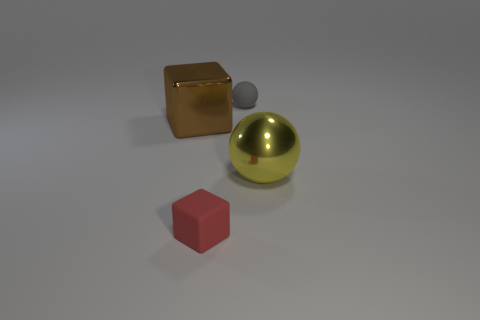Add 4 small brown metal spheres. How many objects exist? 8 Subtract all yellow balls. How many balls are left? 1 Subtract 2 cubes. How many cubes are left? 0 Subtract 1 yellow spheres. How many objects are left? 3 Subtract all green spheres. Subtract all red cylinders. How many spheres are left? 2 Subtract all cyan metallic cylinders. Subtract all big balls. How many objects are left? 3 Add 3 big objects. How many big objects are left? 5 Add 1 large brown metal blocks. How many large brown metal blocks exist? 2 